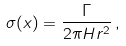<formula> <loc_0><loc_0><loc_500><loc_500>\sigma ( x ) = \frac { \Gamma } { 2 \pi H r ^ { 2 } } \, ,</formula> 